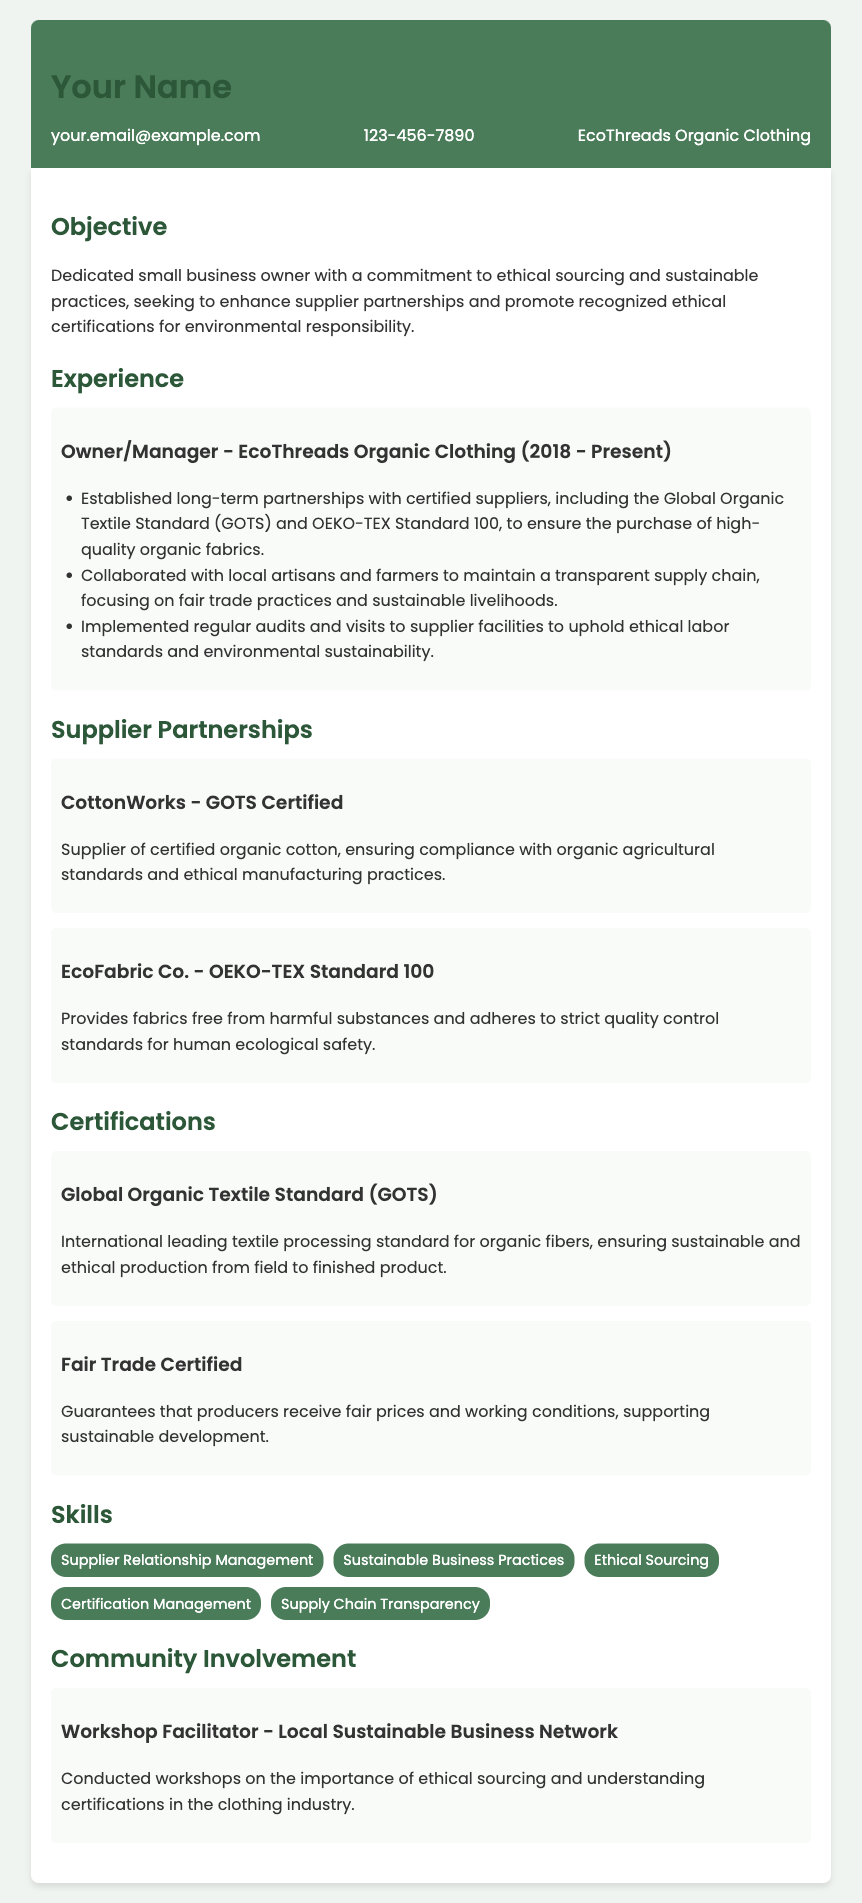What is the name of the business? The business name is mentioned in the contact information section of the document.
Answer: EcoThreads Organic Clothing Who is the owner/manager of EcoThreads Organic Clothing? The resume states the owner's position in the experience section, where they are identified in their role.
Answer: Owner/Manager What certification does CottonWorks have? The specific certification for CottonWorks is listed in the Supplier Partnerships section.
Answer: GOTS Certified What is the main objective of the business owner? The objective is outlined in the objective section of the document, focusing on their commitment.
Answer: Ethical sourcing and sustainable practices Which certification guarantees fair prices for producers? The certification related to fair pricing for producers is identified in the Certifications section.
Answer: Fair Trade Certified What are two key suppliers mentioned? The resume specifically lists these suppliers in the Supplier Partnerships section, indicating important partnerships.
Answer: CottonWorks and EcoFabric Co How many years has the business been operating? The duration of operation is given in the experience section under the business title.
Answer: 5 years What is one skill listed under skills? Skills relevant to the business are listed in the Skills section, indicating competencies of the owner.
Answer: Supplier Relationship Management 